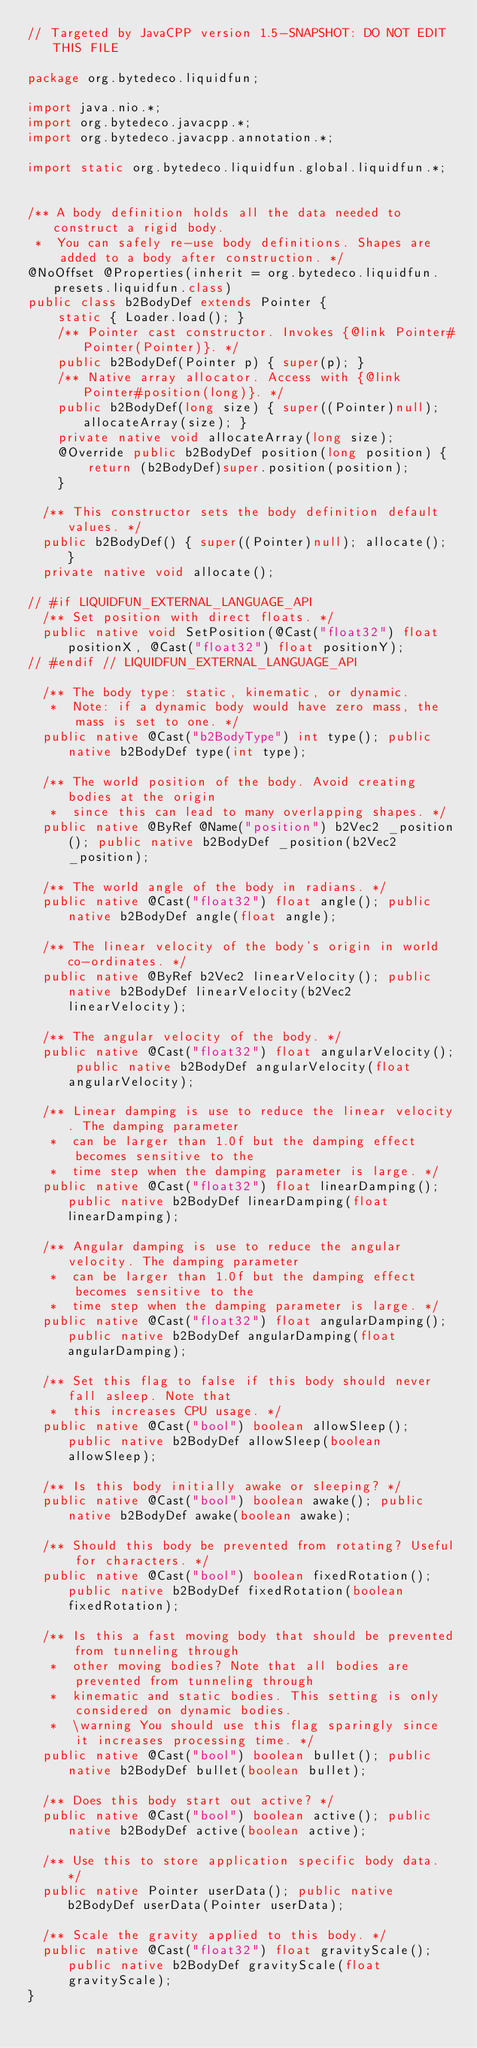Convert code to text. <code><loc_0><loc_0><loc_500><loc_500><_Java_>// Targeted by JavaCPP version 1.5-SNAPSHOT: DO NOT EDIT THIS FILE

package org.bytedeco.liquidfun;

import java.nio.*;
import org.bytedeco.javacpp.*;
import org.bytedeco.javacpp.annotation.*;

import static org.bytedeco.liquidfun.global.liquidfun.*;


/** A body definition holds all the data needed to construct a rigid body.
 *  You can safely re-use body definitions. Shapes are added to a body after construction. */
@NoOffset @Properties(inherit = org.bytedeco.liquidfun.presets.liquidfun.class)
public class b2BodyDef extends Pointer {
    static { Loader.load(); }
    /** Pointer cast constructor. Invokes {@link Pointer#Pointer(Pointer)}. */
    public b2BodyDef(Pointer p) { super(p); }
    /** Native array allocator. Access with {@link Pointer#position(long)}. */
    public b2BodyDef(long size) { super((Pointer)null); allocateArray(size); }
    private native void allocateArray(long size);
    @Override public b2BodyDef position(long position) {
        return (b2BodyDef)super.position(position);
    }

	/** This constructor sets the body definition default values. */
	public b2BodyDef() { super((Pointer)null); allocate(); }
	private native void allocate();

// #if LIQUIDFUN_EXTERNAL_LANGUAGE_API
	/** Set position with direct floats. */
	public native void SetPosition(@Cast("float32") float positionX, @Cast("float32") float positionY);
// #endif // LIQUIDFUN_EXTERNAL_LANGUAGE_API

	/** The body type: static, kinematic, or dynamic.
	 *  Note: if a dynamic body would have zero mass, the mass is set to one. */
	public native @Cast("b2BodyType") int type(); public native b2BodyDef type(int type);

	/** The world position of the body. Avoid creating bodies at the origin
	 *  since this can lead to many overlapping shapes. */
	public native @ByRef @Name("position") b2Vec2 _position(); public native b2BodyDef _position(b2Vec2 _position);

	/** The world angle of the body in radians. */
	public native @Cast("float32") float angle(); public native b2BodyDef angle(float angle);

	/** The linear velocity of the body's origin in world co-ordinates. */
	public native @ByRef b2Vec2 linearVelocity(); public native b2BodyDef linearVelocity(b2Vec2 linearVelocity);

	/** The angular velocity of the body. */
	public native @Cast("float32") float angularVelocity(); public native b2BodyDef angularVelocity(float angularVelocity);

	/** Linear damping is use to reduce the linear velocity. The damping parameter
	 *  can be larger than 1.0f but the damping effect becomes sensitive to the
	 *  time step when the damping parameter is large. */
	public native @Cast("float32") float linearDamping(); public native b2BodyDef linearDamping(float linearDamping);

	/** Angular damping is use to reduce the angular velocity. The damping parameter
	 *  can be larger than 1.0f but the damping effect becomes sensitive to the
	 *  time step when the damping parameter is large. */
	public native @Cast("float32") float angularDamping(); public native b2BodyDef angularDamping(float angularDamping);

	/** Set this flag to false if this body should never fall asleep. Note that
	 *  this increases CPU usage. */
	public native @Cast("bool") boolean allowSleep(); public native b2BodyDef allowSleep(boolean allowSleep);

	/** Is this body initially awake or sleeping? */
	public native @Cast("bool") boolean awake(); public native b2BodyDef awake(boolean awake);

	/** Should this body be prevented from rotating? Useful for characters. */
	public native @Cast("bool") boolean fixedRotation(); public native b2BodyDef fixedRotation(boolean fixedRotation);

	/** Is this a fast moving body that should be prevented from tunneling through
	 *  other moving bodies? Note that all bodies are prevented from tunneling through
	 *  kinematic and static bodies. This setting is only considered on dynamic bodies.
	 *  \warning You should use this flag sparingly since it increases processing time. */
	public native @Cast("bool") boolean bullet(); public native b2BodyDef bullet(boolean bullet);

	/** Does this body start out active? */
	public native @Cast("bool") boolean active(); public native b2BodyDef active(boolean active);

	/** Use this to store application specific body data. */
	public native Pointer userData(); public native b2BodyDef userData(Pointer userData);

	/** Scale the gravity applied to this body. */
	public native @Cast("float32") float gravityScale(); public native b2BodyDef gravityScale(float gravityScale);
}
</code> 